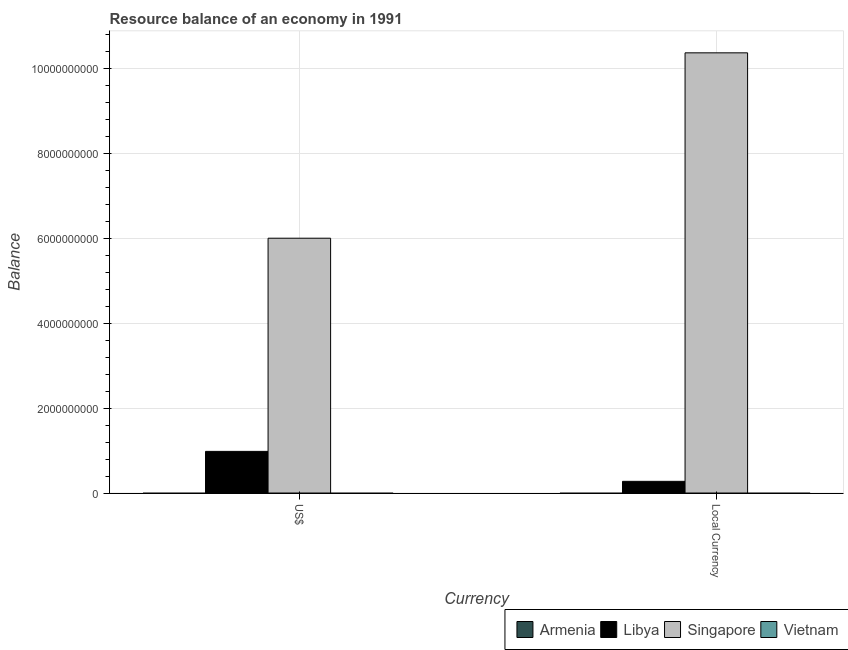How many groups of bars are there?
Make the answer very short. 2. Are the number of bars per tick equal to the number of legend labels?
Keep it short and to the point. No. What is the label of the 2nd group of bars from the left?
Your answer should be very brief. Local Currency. What is the resource balance in constant us$ in Singapore?
Give a very brief answer. 1.04e+1. Across all countries, what is the maximum resource balance in us$?
Provide a succinct answer. 6.00e+09. Across all countries, what is the minimum resource balance in constant us$?
Offer a terse response. 0. In which country was the resource balance in constant us$ maximum?
Your answer should be very brief. Singapore. What is the total resource balance in us$ in the graph?
Give a very brief answer. 6.98e+09. What is the difference between the resource balance in constant us$ in Libya and that in Singapore?
Offer a terse response. -1.01e+1. What is the difference between the resource balance in us$ in Armenia and the resource balance in constant us$ in Libya?
Provide a succinct answer. -2.75e+08. What is the average resource balance in us$ per country?
Give a very brief answer. 1.75e+09. What is the difference between the resource balance in constant us$ and resource balance in us$ in Singapore?
Your response must be concise. 4.37e+09. What is the ratio of the resource balance in us$ in Singapore to that in Libya?
Keep it short and to the point. 6.12. How many bars are there?
Your response must be concise. 4. Are all the bars in the graph horizontal?
Give a very brief answer. No. How many countries are there in the graph?
Ensure brevity in your answer.  4. Are the values on the major ticks of Y-axis written in scientific E-notation?
Your answer should be very brief. No. Does the graph contain grids?
Keep it short and to the point. Yes. Where does the legend appear in the graph?
Your answer should be very brief. Bottom right. How many legend labels are there?
Make the answer very short. 4. What is the title of the graph?
Give a very brief answer. Resource balance of an economy in 1991. Does "Nepal" appear as one of the legend labels in the graph?
Your response must be concise. No. What is the label or title of the X-axis?
Ensure brevity in your answer.  Currency. What is the label or title of the Y-axis?
Provide a succinct answer. Balance. What is the Balance in Armenia in US$?
Your response must be concise. 0. What is the Balance in Libya in US$?
Your answer should be very brief. 9.81e+08. What is the Balance in Singapore in US$?
Offer a terse response. 6.00e+09. What is the Balance of Armenia in Local Currency?
Give a very brief answer. 0. What is the Balance of Libya in Local Currency?
Give a very brief answer. 2.75e+08. What is the Balance of Singapore in Local Currency?
Offer a very short reply. 1.04e+1. Across all Currency, what is the maximum Balance in Libya?
Keep it short and to the point. 9.81e+08. Across all Currency, what is the maximum Balance of Singapore?
Offer a terse response. 1.04e+1. Across all Currency, what is the minimum Balance in Libya?
Your answer should be compact. 2.75e+08. Across all Currency, what is the minimum Balance in Singapore?
Provide a short and direct response. 6.00e+09. What is the total Balance of Armenia in the graph?
Provide a succinct answer. 0. What is the total Balance of Libya in the graph?
Offer a terse response. 1.26e+09. What is the total Balance of Singapore in the graph?
Give a very brief answer. 1.64e+1. What is the difference between the Balance of Libya in US$ and that in Local Currency?
Your answer should be compact. 7.06e+08. What is the difference between the Balance of Singapore in US$ and that in Local Currency?
Provide a short and direct response. -4.37e+09. What is the difference between the Balance in Libya in US$ and the Balance in Singapore in Local Currency?
Provide a short and direct response. -9.39e+09. What is the average Balance in Armenia per Currency?
Give a very brief answer. 0. What is the average Balance in Libya per Currency?
Ensure brevity in your answer.  6.28e+08. What is the average Balance in Singapore per Currency?
Your answer should be compact. 8.19e+09. What is the difference between the Balance of Libya and Balance of Singapore in US$?
Your response must be concise. -5.02e+09. What is the difference between the Balance of Libya and Balance of Singapore in Local Currency?
Keep it short and to the point. -1.01e+1. What is the ratio of the Balance of Libya in US$ to that in Local Currency?
Keep it short and to the point. 3.56. What is the ratio of the Balance of Singapore in US$ to that in Local Currency?
Make the answer very short. 0.58. What is the difference between the highest and the second highest Balance of Libya?
Your answer should be compact. 7.06e+08. What is the difference between the highest and the second highest Balance of Singapore?
Offer a very short reply. 4.37e+09. What is the difference between the highest and the lowest Balance in Libya?
Keep it short and to the point. 7.06e+08. What is the difference between the highest and the lowest Balance in Singapore?
Keep it short and to the point. 4.37e+09. 